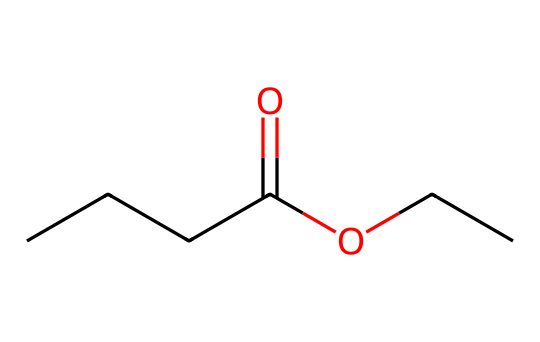What is the molecular formula of this compound? By examining the structure, we count the number of carbon (C), hydrogen (H), and oxygen (O) atoms. There are 5 carbons, 10 hydrogens, and 2 oxygens in the structure. Thus, the molecular formula is C5H10O2.
Answer: C5H10O2 How many carbon atoms are present in ethyl butyrate? The visual representation shows a total of 5 carbon atoms in the skeletal structure.
Answer: 5 What type of functional group does ethyl butyrate contain? The structure reveals a carboxylic acid derivative, specifically an ester functional group indicated by the COO part of the structure.
Answer: ester Why does ethyl butyrate have a fruity aroma? The fruity aroma is attributed to the specific ester functional group present in the compound, which is known to contribute to sweet and fruity smells. This is because esters are commonly associated with characteristic aromas.
Answer: fruity How many oxygen atoms are in ethyl butyrate? In the chemical structure, we can clearly identify 2 oxygen atoms.
Answer: 2 What is the common use of ethyl butyrate in food? Ethyl butyrate is commonly used as a flavoring agent in food products, especially in fruity flavors like pineapple and apple.
Answer: flavoring agent What property of ethyl butyrate makes it suitable for use in perfumes? Ethyl butyrate's volatility due to its low molecular weight and its pleasant fruity aroma make it suitable for use in perfumes.
Answer: volatility 